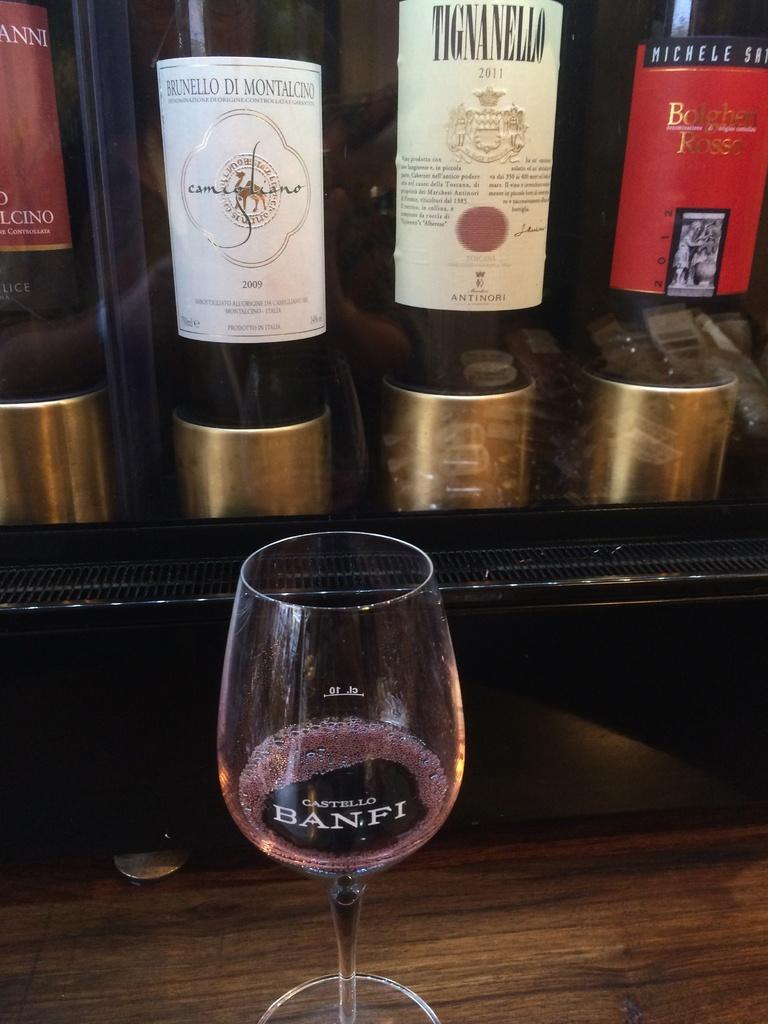What year is the tigneallo wine?
Ensure brevity in your answer.  2011. 